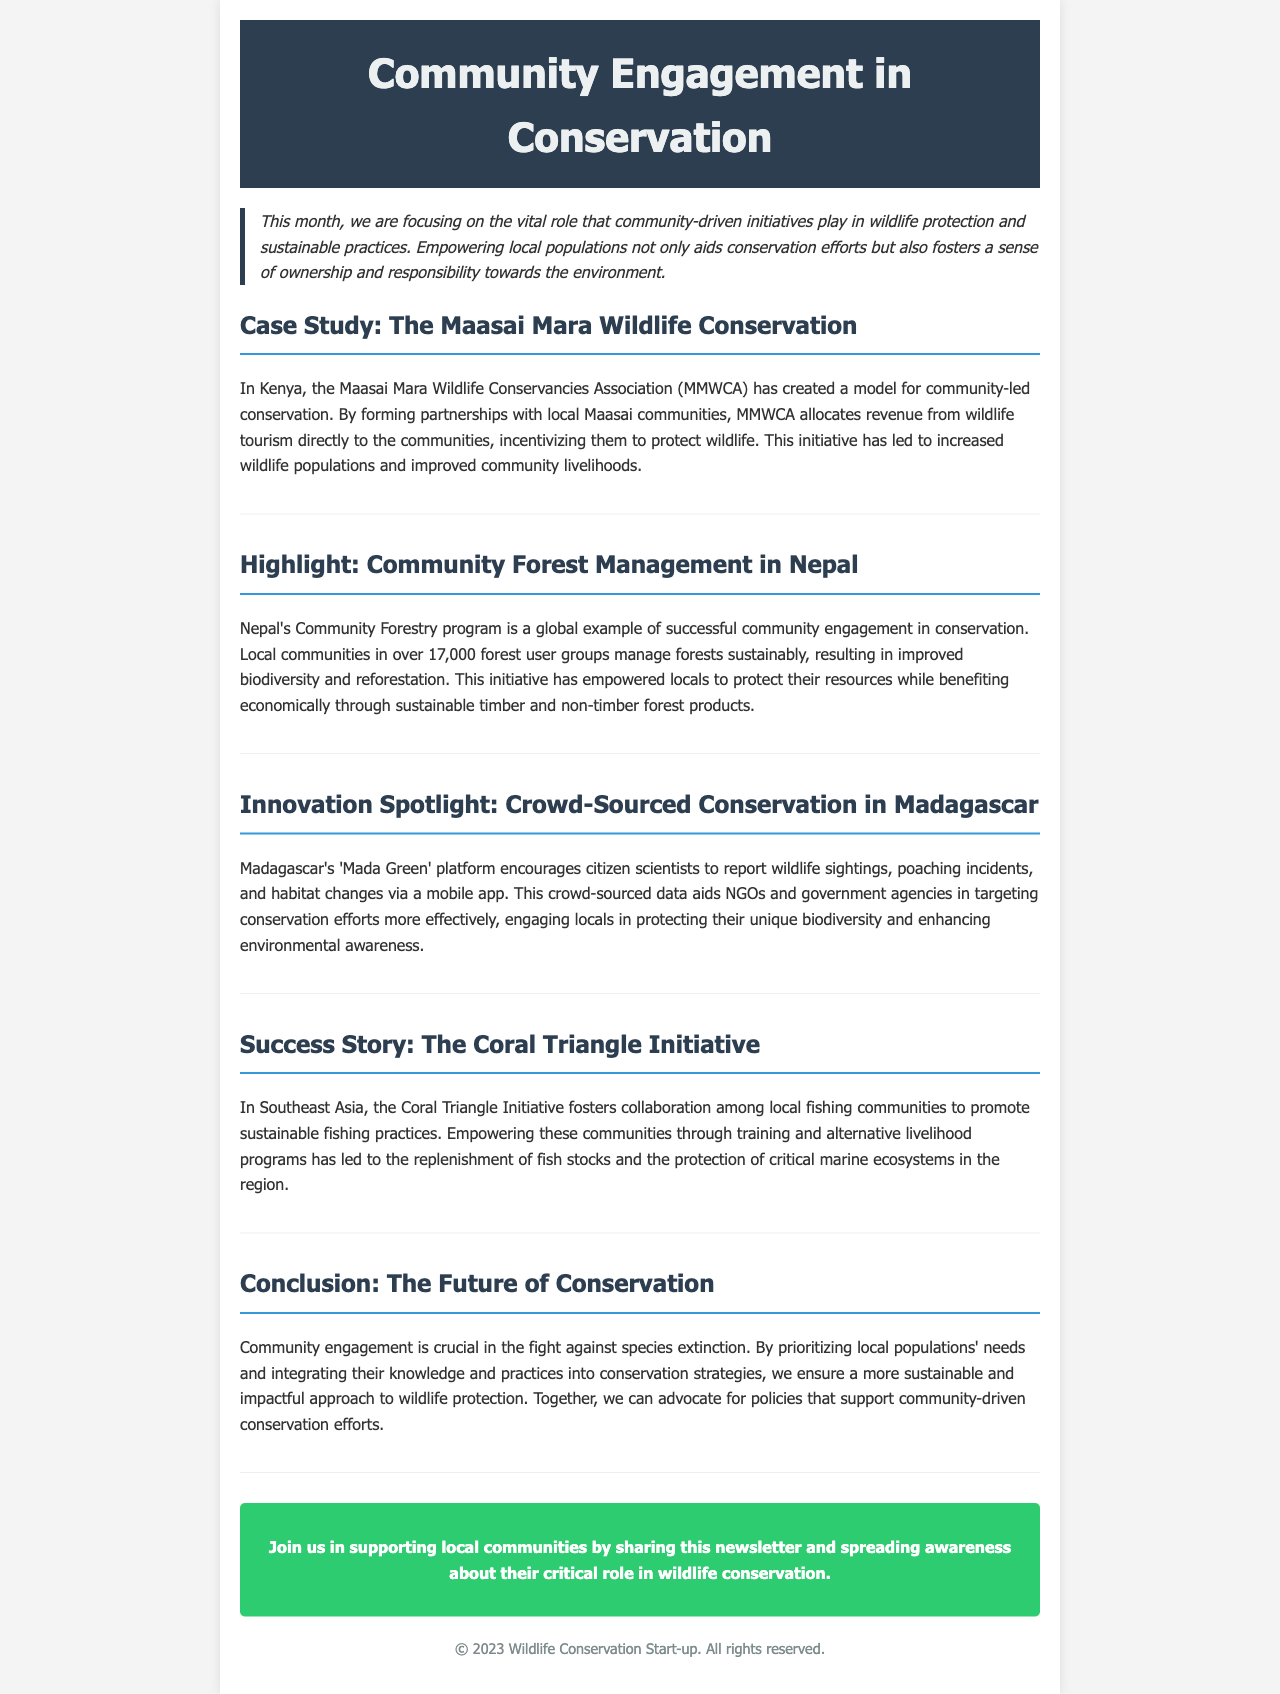What is the title of the newsletter? The title is prominently displayed at the top of the document.
Answer: Community Engagement in Conservation Which organization is involved in the Maasai Mara Wildlife Conservation? The organization is mentioned in the case study section.
Answer: Maasai Mara Wildlife Conservancies Association (MMWCA) How many forest user groups are part of Nepal's Community Forestry program? The number is provided in the highlight section of the newsletter.
Answer: Over 17,000 What is the name of the crowd-sourced conservation platform in Madagascar? The name of the platform is highlighted in the innovation spotlight section.
Answer: Mada Green What is a key outcome of the Coral Triangle Initiative? The document specifies the impact of the initiative in its success story.
Answer: Replenishment of fish stocks What is one of the benefits of community engagement in conservation according to the conclusion? The document outlines the advantages of community involvement in the conclusion section.
Answer: Sustainable and impactful approach 